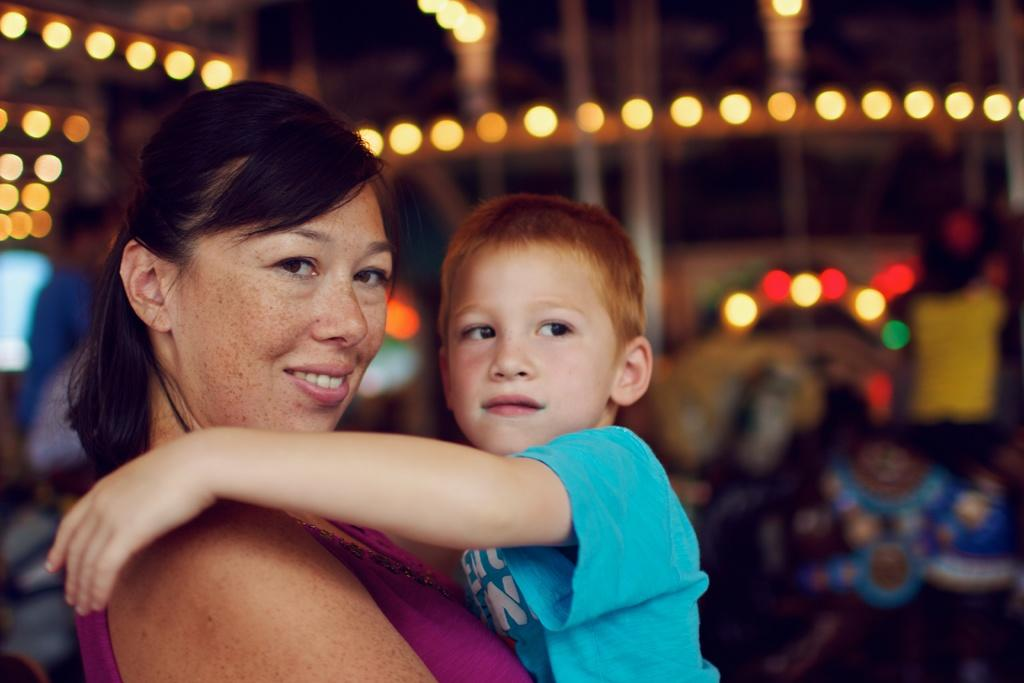Who is the main subject in the image? There is a lady in the image. What is the lady doing in the image? The lady is standing and holding a boy. What can be seen in the background of the image? There are lights in the background of the image. What type of bead is the lady wearing in the image? There is no bead visible on the lady in the image. Can you tell me the total cost of the items the lady purchased, as shown on the receipt in the image? There is no receipt present in the image. 